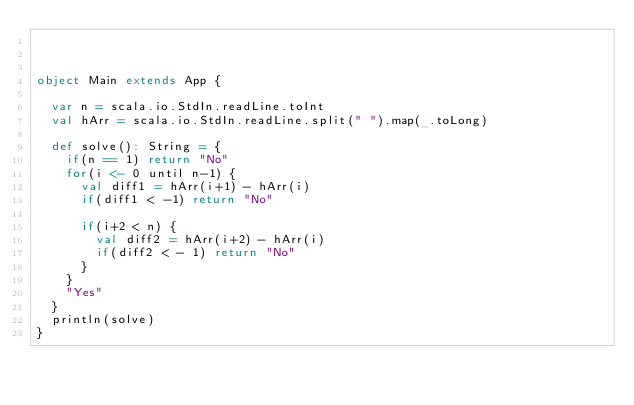Convert code to text. <code><loc_0><loc_0><loc_500><loc_500><_Scala_>


object Main extends App {

  var n = scala.io.StdIn.readLine.toInt
  val hArr = scala.io.StdIn.readLine.split(" ").map(_.toLong)

  def solve(): String = {
    if(n == 1) return "No"
    for(i <- 0 until n-1) {
      val diff1 = hArr(i+1) - hArr(i)
      if(diff1 < -1) return "No"

      if(i+2 < n) {
        val diff2 = hArr(i+2) - hArr(i)
        if(diff2 < - 1) return "No"
      }
    }
    "Yes"
  }
  println(solve)
}
</code> 